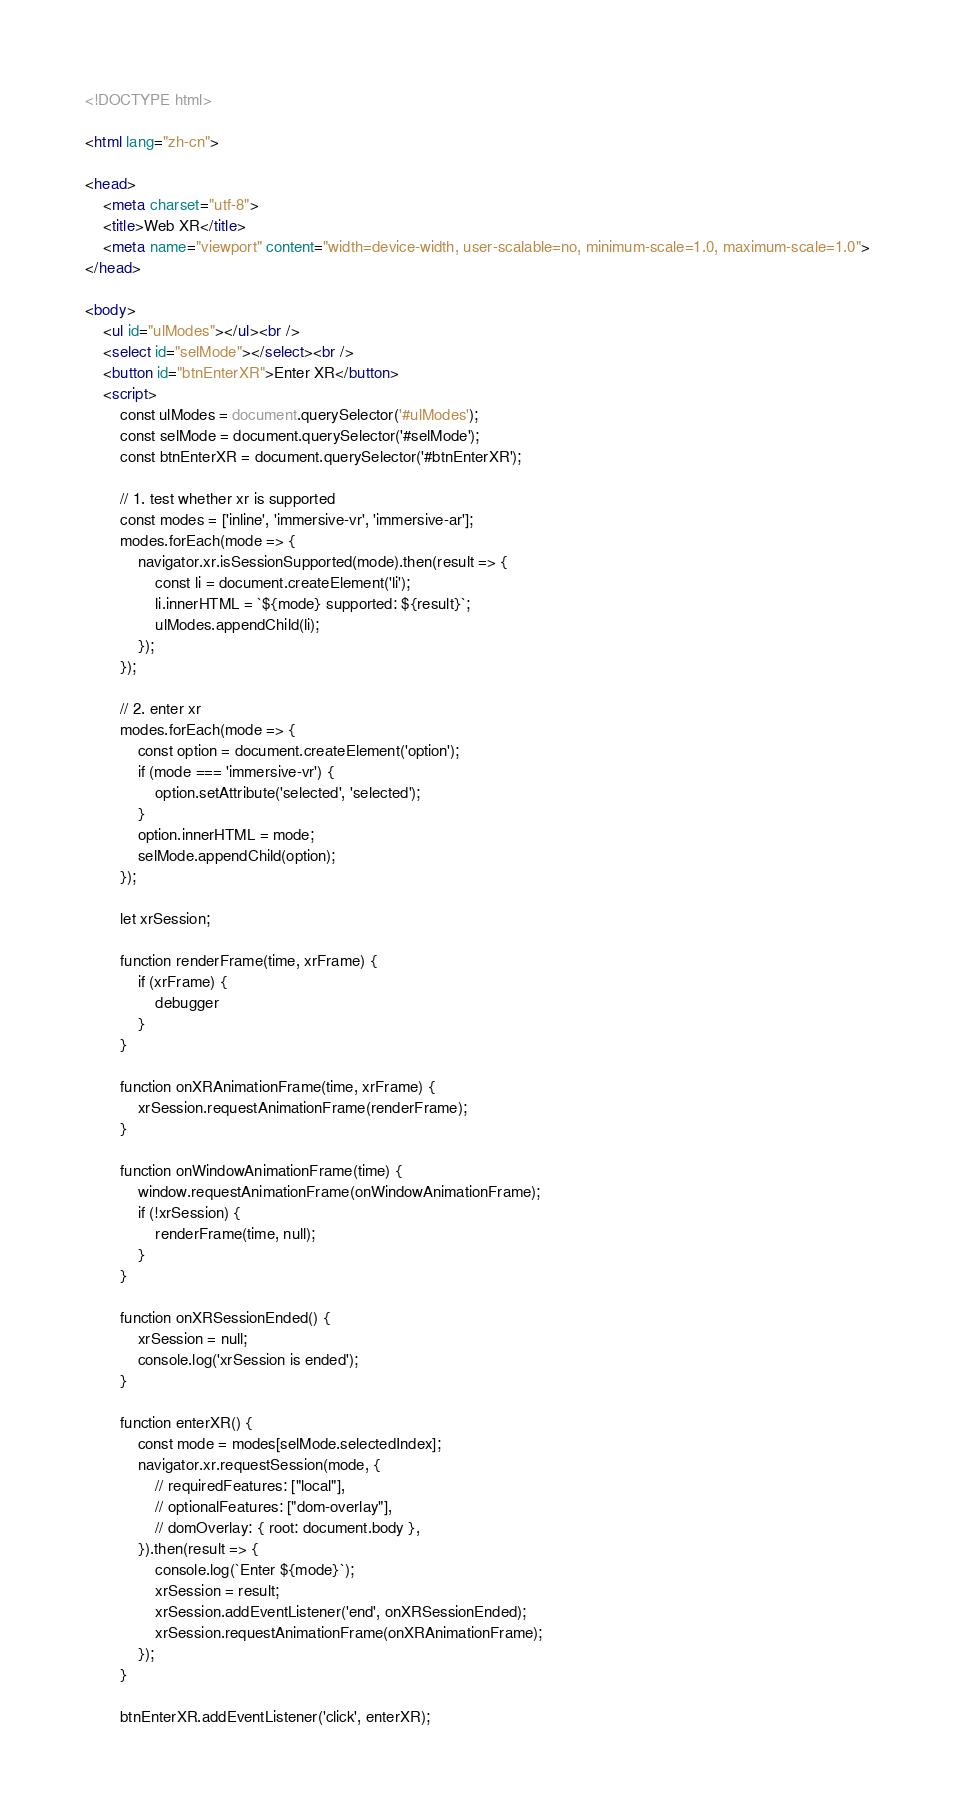<code> <loc_0><loc_0><loc_500><loc_500><_HTML_><!DOCTYPE html>

<html lang="zh-cn">

<head>
    <meta charset="utf-8">
    <title>Web XR</title>
    <meta name="viewport" content="width=device-width, user-scalable=no, minimum-scale=1.0, maximum-scale=1.0">
</head>

<body>
    <ul id="ulModes"></ul><br />
    <select id="selMode"></select><br />
    <button id="btnEnterXR">Enter XR</button>
    <script>
        const ulModes = document.querySelector('#ulModes');
        const selMode = document.querySelector('#selMode');
        const btnEnterXR = document.querySelector('#btnEnterXR');

        // 1. test whether xr is supported
        const modes = ['inline', 'immersive-vr', 'immersive-ar'];
        modes.forEach(mode => {
            navigator.xr.isSessionSupported(mode).then(result => {
                const li = document.createElement('li');
                li.innerHTML = `${mode} supported: ${result}`;
                ulModes.appendChild(li);
            });
        });

        // 2. enter xr
        modes.forEach(mode => {
            const option = document.createElement('option');
            if (mode === 'immersive-vr') {
                option.setAttribute('selected', 'selected');
            }
            option.innerHTML = mode;
            selMode.appendChild(option);
        });

        let xrSession;

        function renderFrame(time, xrFrame) {
            if (xrFrame) {
                debugger
            }
        }

        function onXRAnimationFrame(time, xrFrame) {
            xrSession.requestAnimationFrame(renderFrame);
        }

        function onWindowAnimationFrame(time) {
            window.requestAnimationFrame(onWindowAnimationFrame);
            if (!xrSession) {
                renderFrame(time, null);
            }
        }

        function onXRSessionEnded() {
            xrSession = null;
            console.log('xrSession is ended');
        }

        function enterXR() {
            const mode = modes[selMode.selectedIndex];
            navigator.xr.requestSession(mode, {
                // requiredFeatures: ["local"],
                // optionalFeatures: ["dom-overlay"],
                // domOverlay: { root: document.body },
            }).then(result => {
                console.log(`Enter ${mode}`);
                xrSession = result;
                xrSession.addEventListener('end', onXRSessionEnded);
                xrSession.requestAnimationFrame(onXRAnimationFrame);
            });
        }

        btnEnterXR.addEventListener('click', enterXR);</code> 